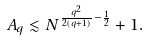<formula> <loc_0><loc_0><loc_500><loc_500>A _ { q } \lesssim N ^ { \frac { q ^ { 2 } } { 2 ( q + 1 ) } - \frac { 1 } { 2 } } + 1 .</formula> 